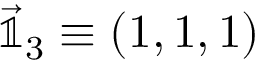Convert formula to latex. <formula><loc_0><loc_0><loc_500><loc_500>\vec { \mathbb { 1 } } _ { 3 } \equiv \left ( 1 , 1 , 1 \right )</formula> 